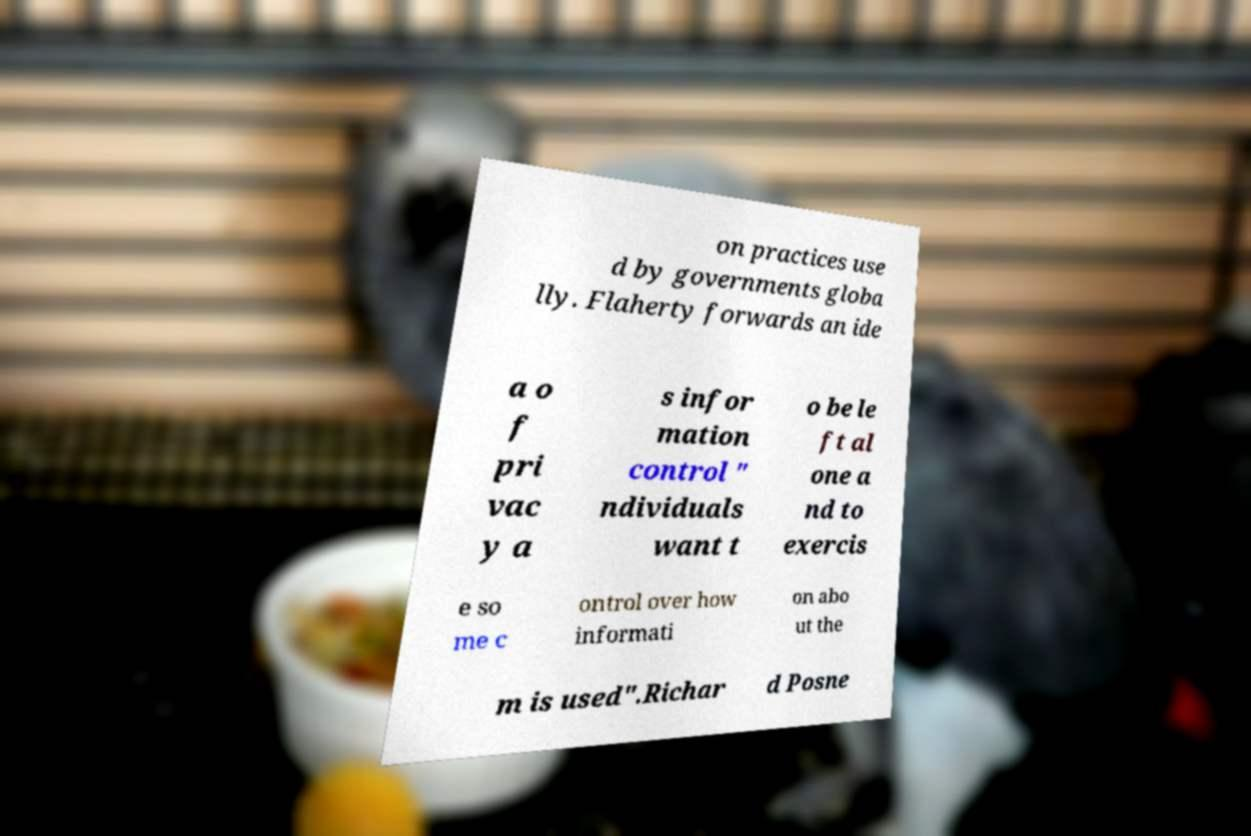What messages or text are displayed in this image? I need them in a readable, typed format. on practices use d by governments globa lly. Flaherty forwards an ide a o f pri vac y a s infor mation control " ndividuals want t o be le ft al one a nd to exercis e so me c ontrol over how informati on abo ut the m is used".Richar d Posne 